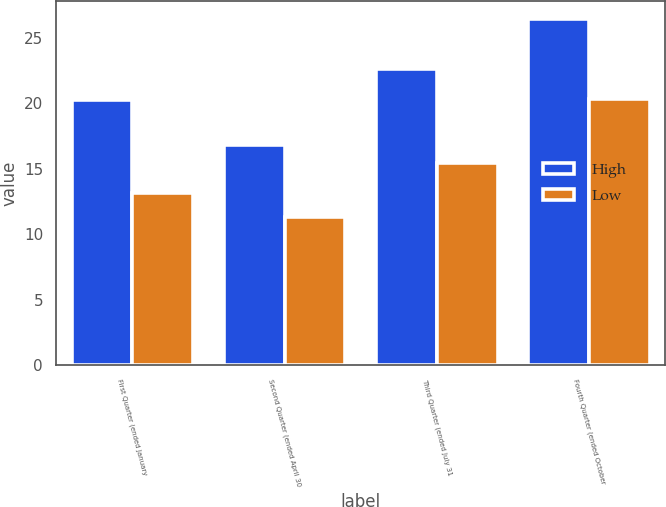Convert chart. <chart><loc_0><loc_0><loc_500><loc_500><stacked_bar_chart><ecel><fcel>First Quarter (ended January<fcel>Second Quarter (ended April 30<fcel>Third Quarter (ended July 31<fcel>Fourth Quarter (ended October<nl><fcel>High<fcel>20.3<fcel>16.82<fcel>22.64<fcel>26.48<nl><fcel>Low<fcel>13.19<fcel>11.3<fcel>15.48<fcel>20.31<nl></chart> 